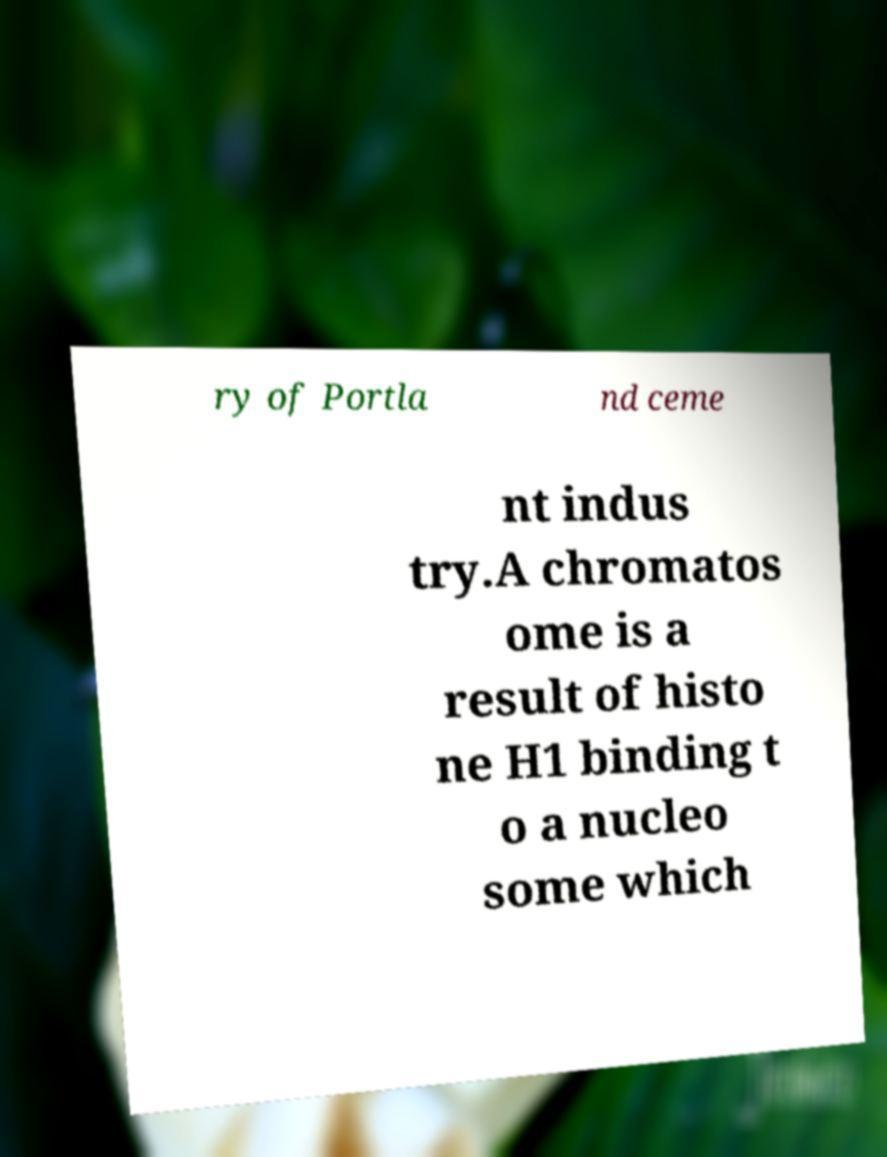There's text embedded in this image that I need extracted. Can you transcribe it verbatim? ry of Portla nd ceme nt indus try.A chromatos ome is a result of histo ne H1 binding t o a nucleo some which 